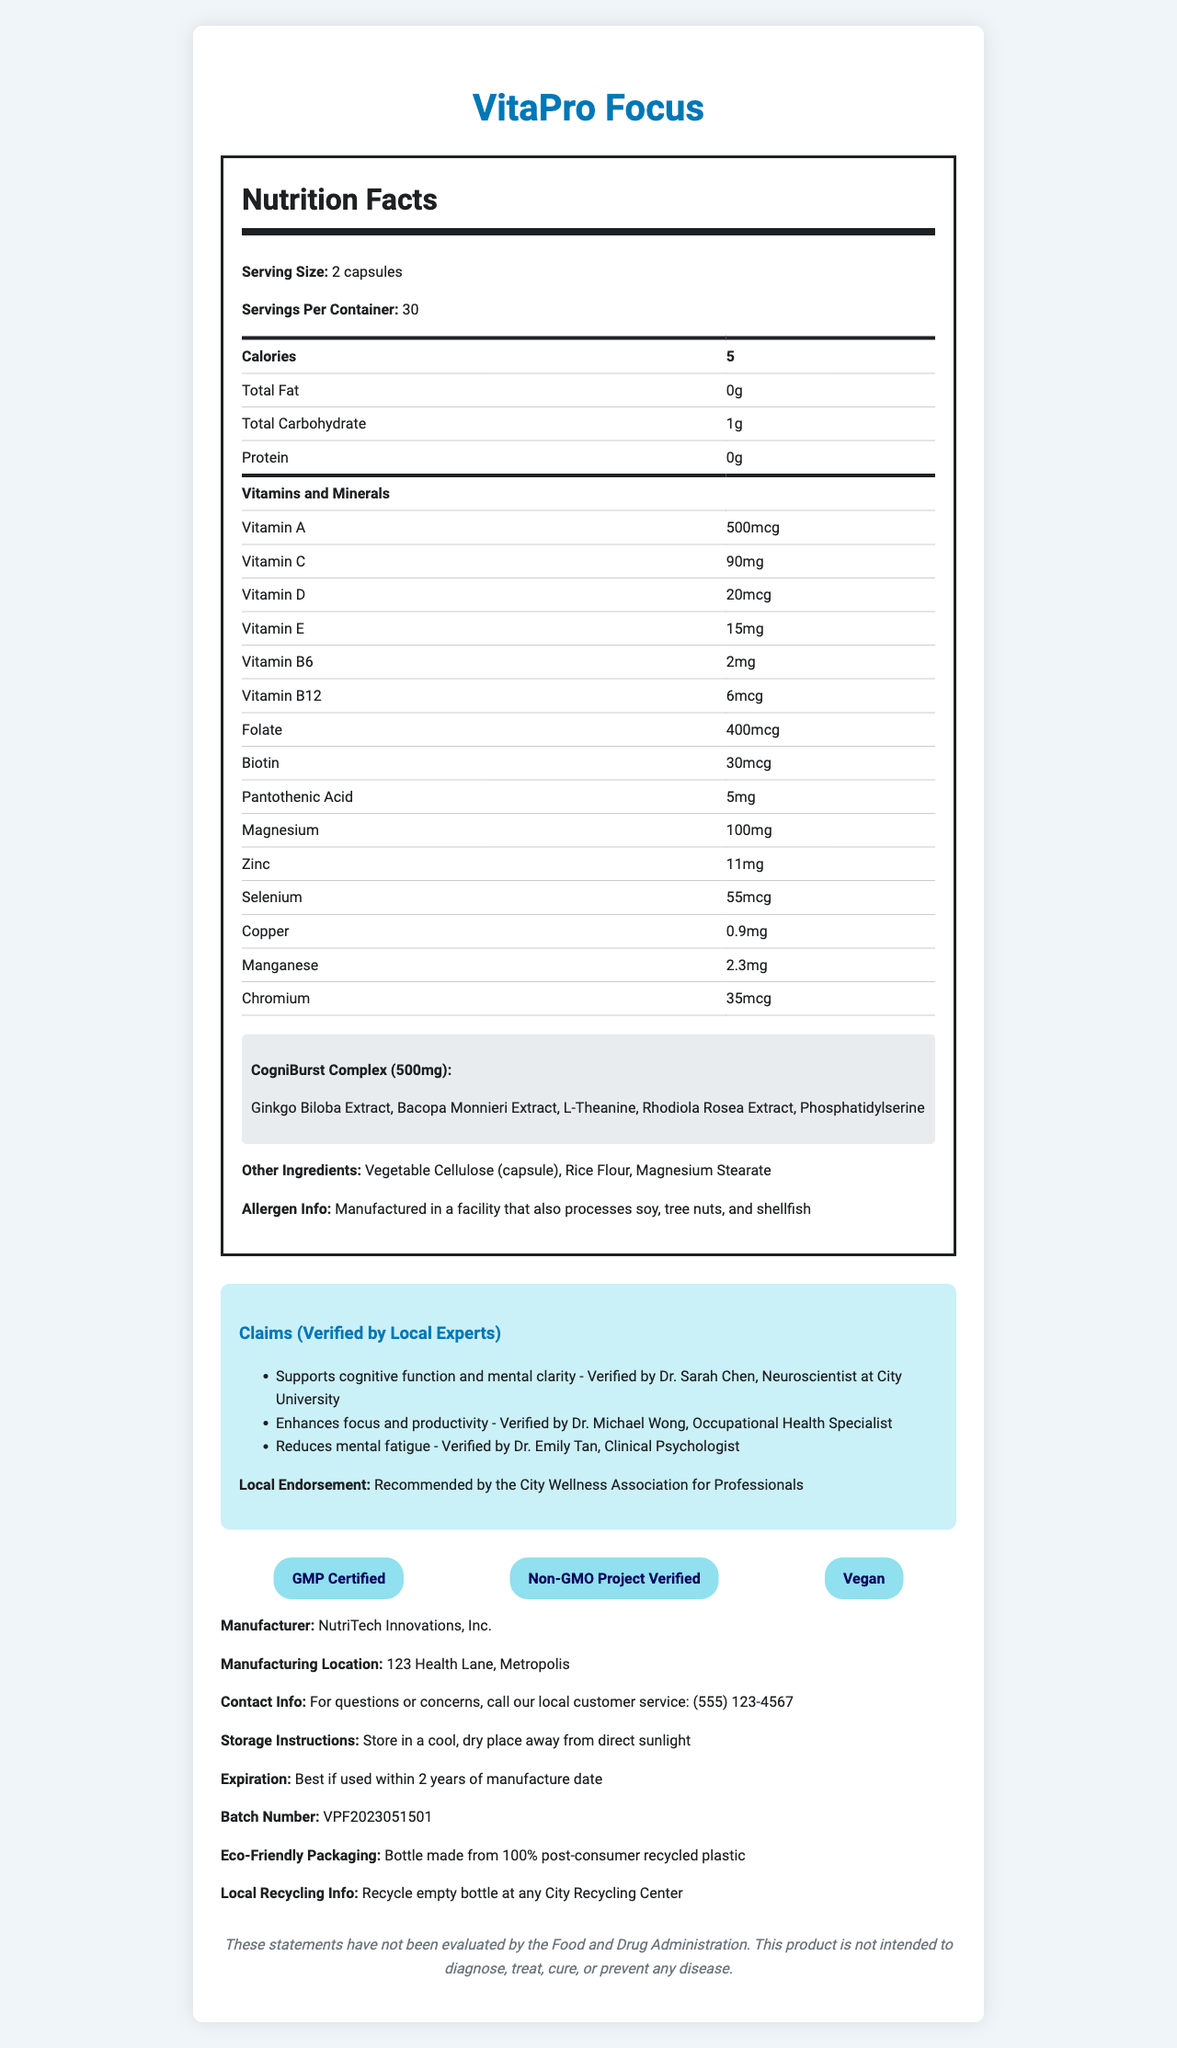what is the serving size? The document specifies that the serving size for VitaPro Focus is 2 capsules.
Answer: 2 capsules How many servings are there per container? The document states that each container consists of 30 servings.
Answer: 30 What is the total carbohydrate content per serving? The document shows that the total carbohydrate content per serving is 1 gram.
Answer: 1g Who verified the claim "Supports cognitive function and mental clarity"? The document shows this specific claim is verified by Dr. Sarah Chen, a Neuroscientist at City University.
Answer: Dr. Sarah Chen, Neuroscientist at City University Where is the manufacturing location for VitaPro Focus? The document provides the manufacturing location as 123 Health Lane, Metropolis.
Answer: 123 Health Lane, Metropolis Which ingredient is not part of the proprietary blend? A. Ginkgo Biloba Extract B. Rice Flour C. Bacopa Monnieri Extract D. L-Theanine Rice Flour is listed as an "other ingredient" and not part of the CogniBurst Complex proprietary blend.
Answer: B. Rice Flour What is the total amount of magnesium per serving? A. 5mg B. 100mg C. 90mg D. 20mcg The document indicates that each serving contains 100mg of magnesium.
Answer: B. 100mg Does this product contain any protein? The nutrition facts section of the document states the protein content as 0 grams.
Answer: No Summarize the main idea of the document. The VitaPro Focus nutrition facts label is designed to offer comprehensive details about the supplement, including its nutritional content, benefits, local endorsements, and manufacturing information.
Answer: The document provides detailed nutrition facts about VitaPro Focus, a health supplement aimed at busy professionals, including serving size, vitamin and mineral content, proprietary blend ingredients, claims verified by local experts, and additional information such as allergen and manufacturing details. Can the verified claims about this product be confirmed by the FDA? The document includes a disclaimer stating that the claims have not been evaluated by the Food and Drug Administration.
Answer: Cannot be determined 